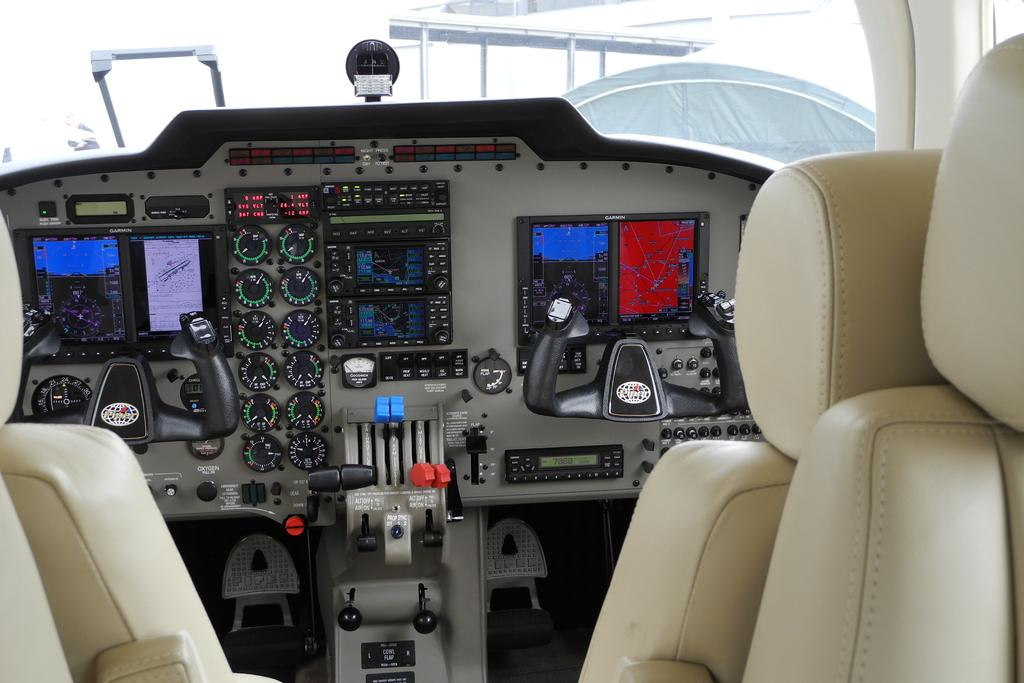What type of location is depicted in the image? The image shows the interior view of a plane. What can be seen outside the plane in the image? There is a building visible in the image. What type of temporary shelter is present in the image? There is a tent in the image. What type of songs can be heard playing in the background of the image? There is no audio or indication of any songs playing in the image. 